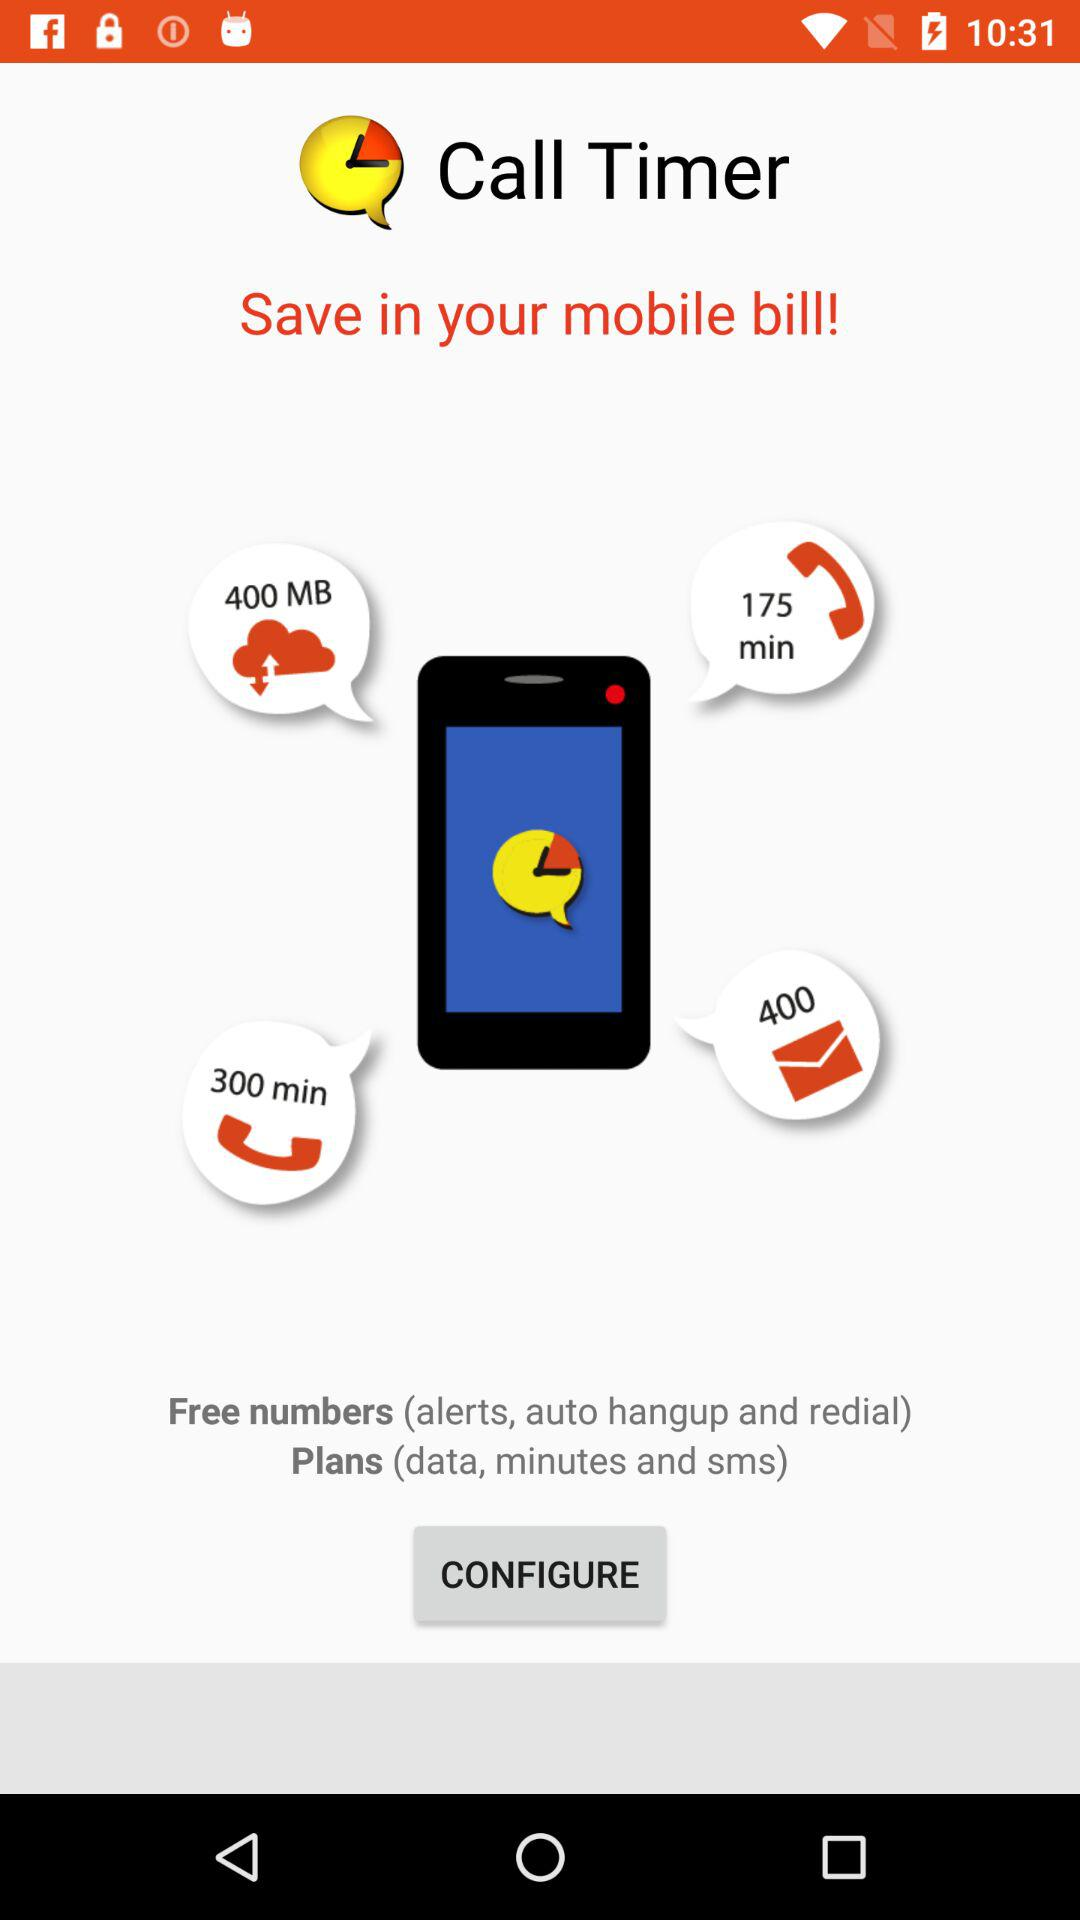What is the application name? The application name is "Call Timer". 